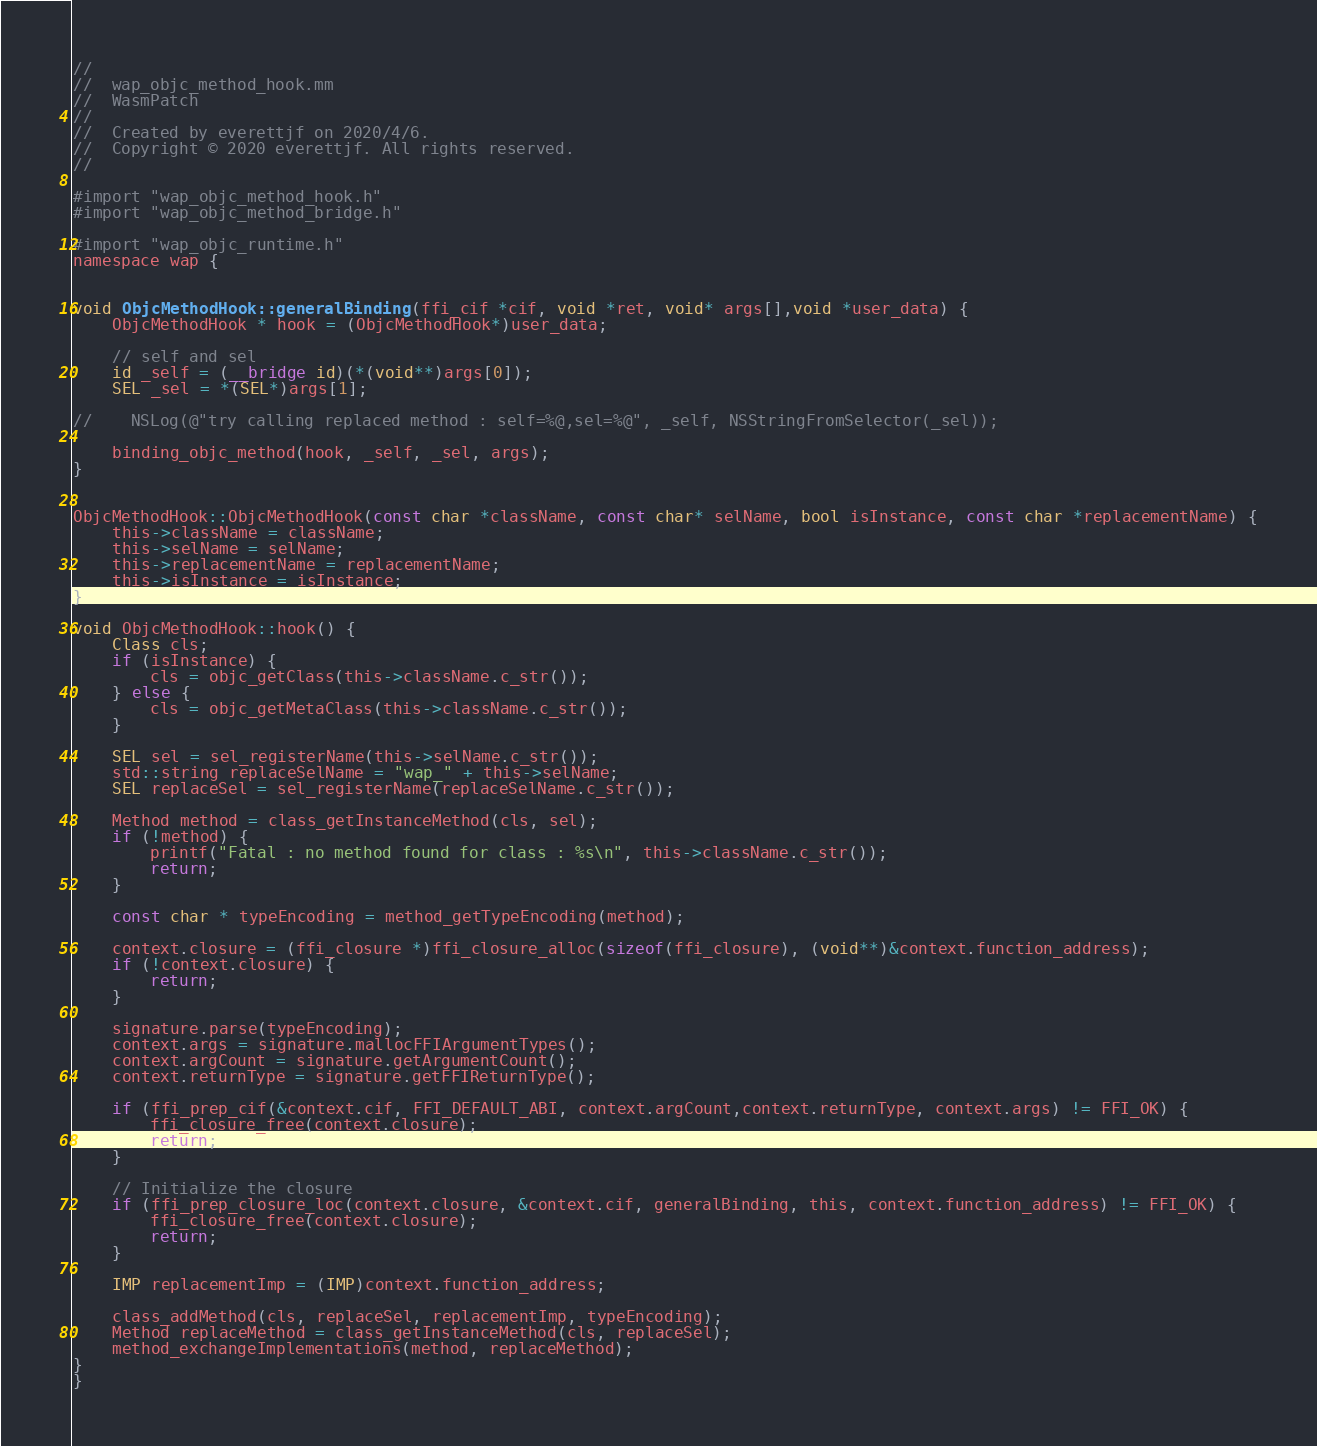<code> <loc_0><loc_0><loc_500><loc_500><_ObjectiveC_>//
//  wap_objc_method_hook.mm
//  WasmPatch
//
//  Created by everettjf on 2020/4/6.
//  Copyright © 2020 everettjf. All rights reserved.
//

#import "wap_objc_method_hook.h"
#import "wap_objc_method_bridge.h"

#import "wap_objc_runtime.h"
namespace wap {


void ObjcMethodHook::generalBinding(ffi_cif *cif, void *ret, void* args[],void *user_data) {
    ObjcMethodHook * hook = (ObjcMethodHook*)user_data;

    // self and sel
    id _self = (__bridge id)(*(void**)args[0]);
    SEL _sel = *(SEL*)args[1];

//    NSLog(@"try calling replaced method : self=%@,sel=%@", _self, NSStringFromSelector(_sel));

    binding_objc_method(hook, _self, _sel, args);
}


ObjcMethodHook::ObjcMethodHook(const char *className, const char* selName, bool isInstance, const char *replacementName) {
    this->className = className;
    this->selName = selName;
    this->replacementName = replacementName;
    this->isInstance = isInstance;
}

void ObjcMethodHook::hook() {
    Class cls;
    if (isInstance) {
        cls = objc_getClass(this->className.c_str());
    } else {
        cls = objc_getMetaClass(this->className.c_str());
    }
    
    SEL sel = sel_registerName(this->selName.c_str());
    std::string replaceSelName = "wap_" + this->selName;
    SEL replaceSel = sel_registerName(replaceSelName.c_str());

    Method method = class_getInstanceMethod(cls, sel);
    if (!method) {
        printf("Fatal : no method found for class : %s\n", this->className.c_str());
        return;
    }

    const char * typeEncoding = method_getTypeEncoding(method);

    context.closure = (ffi_closure *)ffi_closure_alloc(sizeof(ffi_closure), (void**)&context.function_address);
    if (!context.closure) {
        return;
    }

    signature.parse(typeEncoding);
    context.args = signature.mallocFFIArgumentTypes();
    context.argCount = signature.getArgumentCount();
    context.returnType = signature.getFFIReturnType();

    if (ffi_prep_cif(&context.cif, FFI_DEFAULT_ABI, context.argCount,context.returnType, context.args) != FFI_OK) {
        ffi_closure_free(context.closure);
        return;
    }

    // Initialize the closure
    if (ffi_prep_closure_loc(context.closure, &context.cif, generalBinding, this, context.function_address) != FFI_OK) {
        ffi_closure_free(context.closure);
        return;
    }

    IMP replacementImp = (IMP)context.function_address;
    
    class_addMethod(cls, replaceSel, replacementImp, typeEncoding);
    Method replaceMethod = class_getInstanceMethod(cls, replaceSel);
    method_exchangeImplementations(method, replaceMethod);
}
}

</code> 